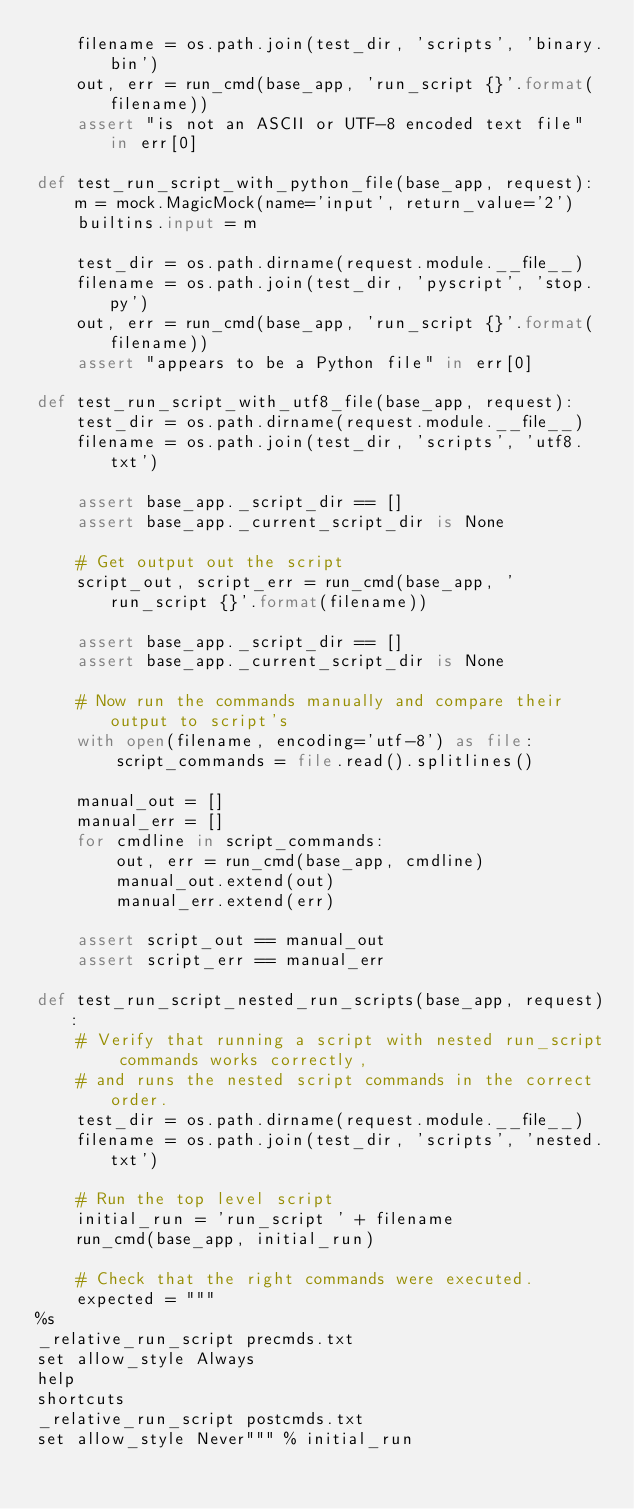<code> <loc_0><loc_0><loc_500><loc_500><_Python_>    filename = os.path.join(test_dir, 'scripts', 'binary.bin')
    out, err = run_cmd(base_app, 'run_script {}'.format(filename))
    assert "is not an ASCII or UTF-8 encoded text file" in err[0]

def test_run_script_with_python_file(base_app, request):
    m = mock.MagicMock(name='input', return_value='2')
    builtins.input = m

    test_dir = os.path.dirname(request.module.__file__)
    filename = os.path.join(test_dir, 'pyscript', 'stop.py')
    out, err = run_cmd(base_app, 'run_script {}'.format(filename))
    assert "appears to be a Python file" in err[0]

def test_run_script_with_utf8_file(base_app, request):
    test_dir = os.path.dirname(request.module.__file__)
    filename = os.path.join(test_dir, 'scripts', 'utf8.txt')

    assert base_app._script_dir == []
    assert base_app._current_script_dir is None

    # Get output out the script
    script_out, script_err = run_cmd(base_app, 'run_script {}'.format(filename))

    assert base_app._script_dir == []
    assert base_app._current_script_dir is None

    # Now run the commands manually and compare their output to script's
    with open(filename, encoding='utf-8') as file:
        script_commands = file.read().splitlines()

    manual_out = []
    manual_err = []
    for cmdline in script_commands:
        out, err = run_cmd(base_app, cmdline)
        manual_out.extend(out)
        manual_err.extend(err)

    assert script_out == manual_out
    assert script_err == manual_err

def test_run_script_nested_run_scripts(base_app, request):
    # Verify that running a script with nested run_script commands works correctly,
    # and runs the nested script commands in the correct order.
    test_dir = os.path.dirname(request.module.__file__)
    filename = os.path.join(test_dir, 'scripts', 'nested.txt')

    # Run the top level script
    initial_run = 'run_script ' + filename
    run_cmd(base_app, initial_run)

    # Check that the right commands were executed.
    expected = """
%s
_relative_run_script precmds.txt
set allow_style Always
help
shortcuts
_relative_run_script postcmds.txt
set allow_style Never""" % initial_run</code> 